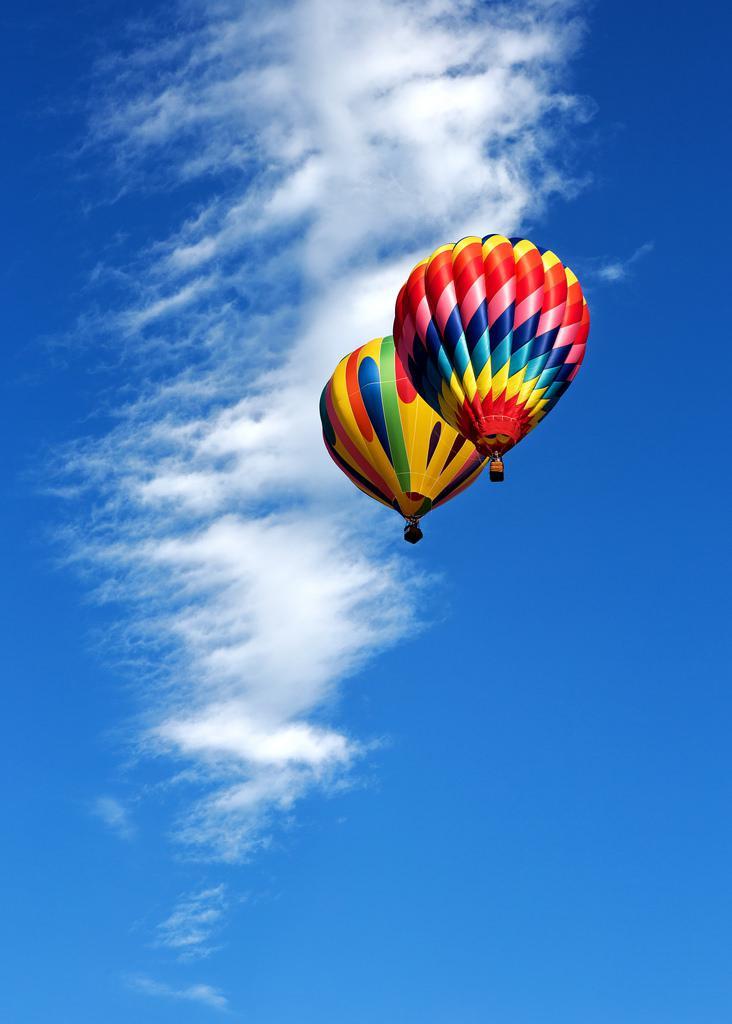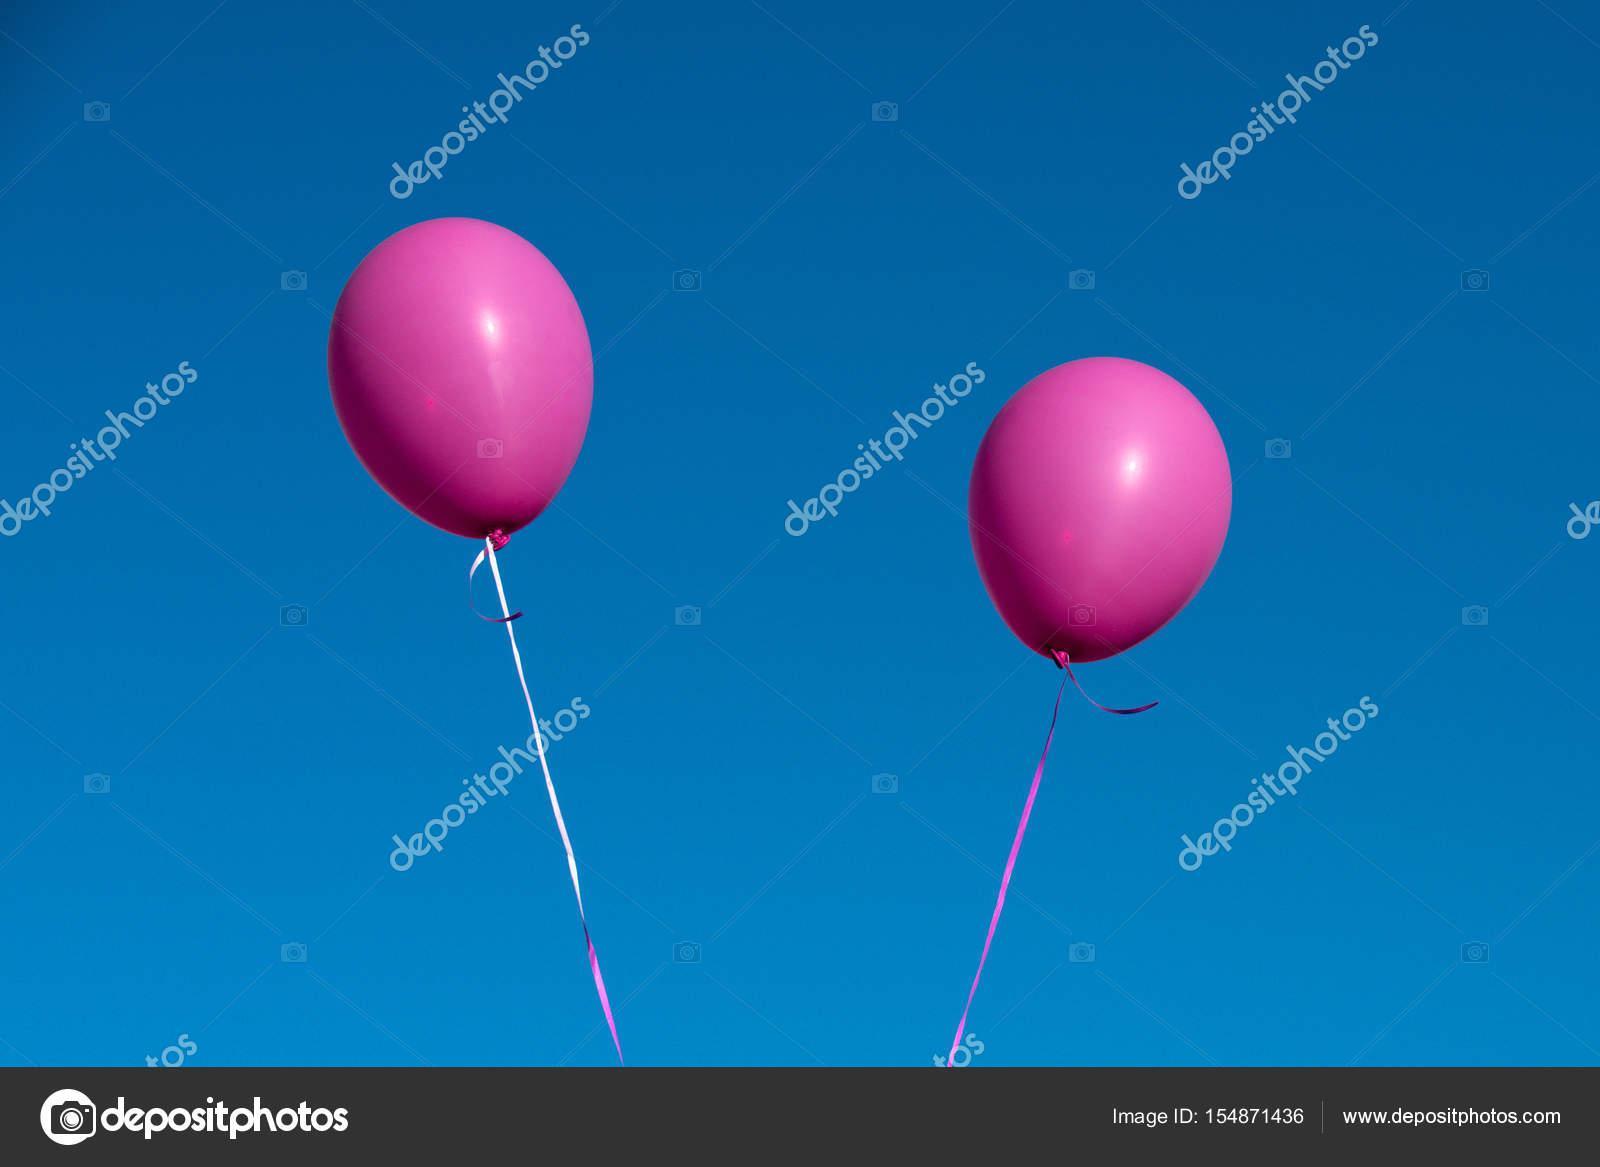The first image is the image on the left, the second image is the image on the right. Considering the images on both sides, is "In at least one of the pictures, all of the balloons are yellow." valid? Answer yes or no. No. The first image is the image on the left, the second image is the image on the right. Analyze the images presented: Is the assertion "An image contains exactly two yellowish balloons against a cloud-scattered blue sky." valid? Answer yes or no. No. 